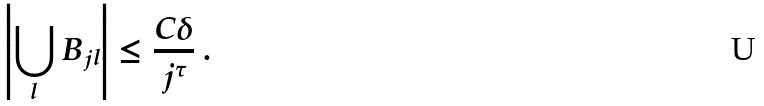Convert formula to latex. <formula><loc_0><loc_0><loc_500><loc_500>\left | \bigcup _ { l } B _ { j l } \right | \leq \frac { C \delta } { j ^ { \tau } } \ .</formula> 